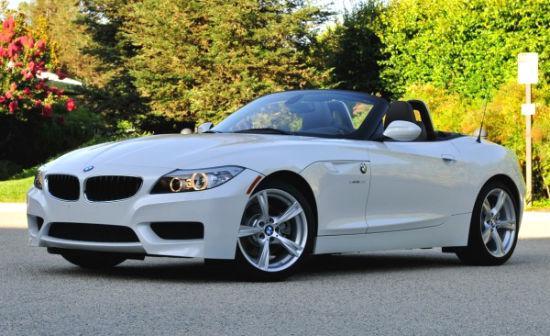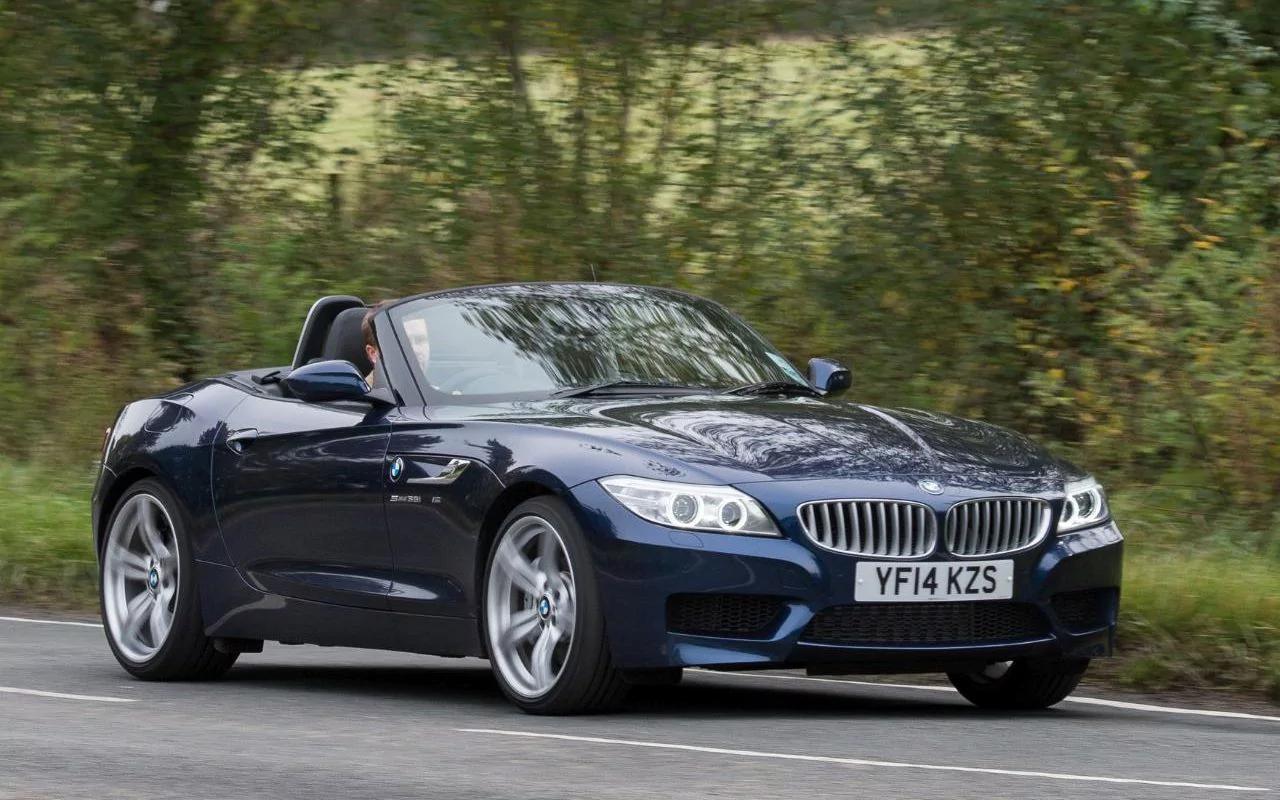The first image is the image on the left, the second image is the image on the right. Considering the images on both sides, is "One of the cars is facing the left and has red seats while the other car faces the right and has beige seats." valid? Answer yes or no. No. The first image is the image on the left, the second image is the image on the right. Assess this claim about the two images: "The left image contains a white convertible that is parked facing towards the left.". Correct or not? Answer yes or no. Yes. 